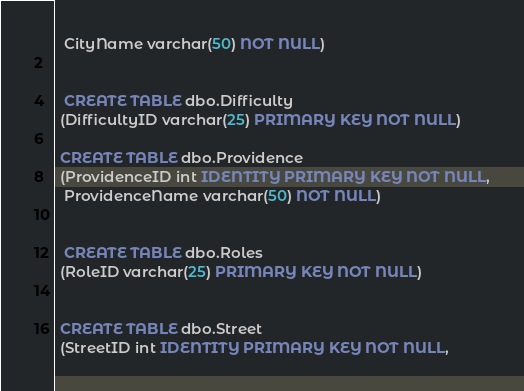Convert code to text. <code><loc_0><loc_0><loc_500><loc_500><_SQL_>  CityName varchar(50) NOT NULL)


  CREATE TABLE dbo.Difficulty
 (DifficultyID varchar(25) PRIMARY KEY NOT NULL)

 CREATE TABLE dbo.Providence
 (ProvidenceID int IDENTITY PRIMARY KEY NOT NULL,
  ProvidenceName varchar(50) NOT NULL)


  CREATE TABLE dbo.Roles
 (RoleID varchar(25) PRIMARY KEY NOT NULL)


 CREATE TABLE dbo.Street
 (StreetID int IDENTITY PRIMARY KEY NOT NULL,</code> 